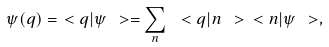Convert formula to latex. <formula><loc_0><loc_0><loc_500><loc_500>\psi ( q ) = \ < q | \psi \ > = \sum _ { n } \, \ < q | n \ > \ < n | \psi \ > ,</formula> 